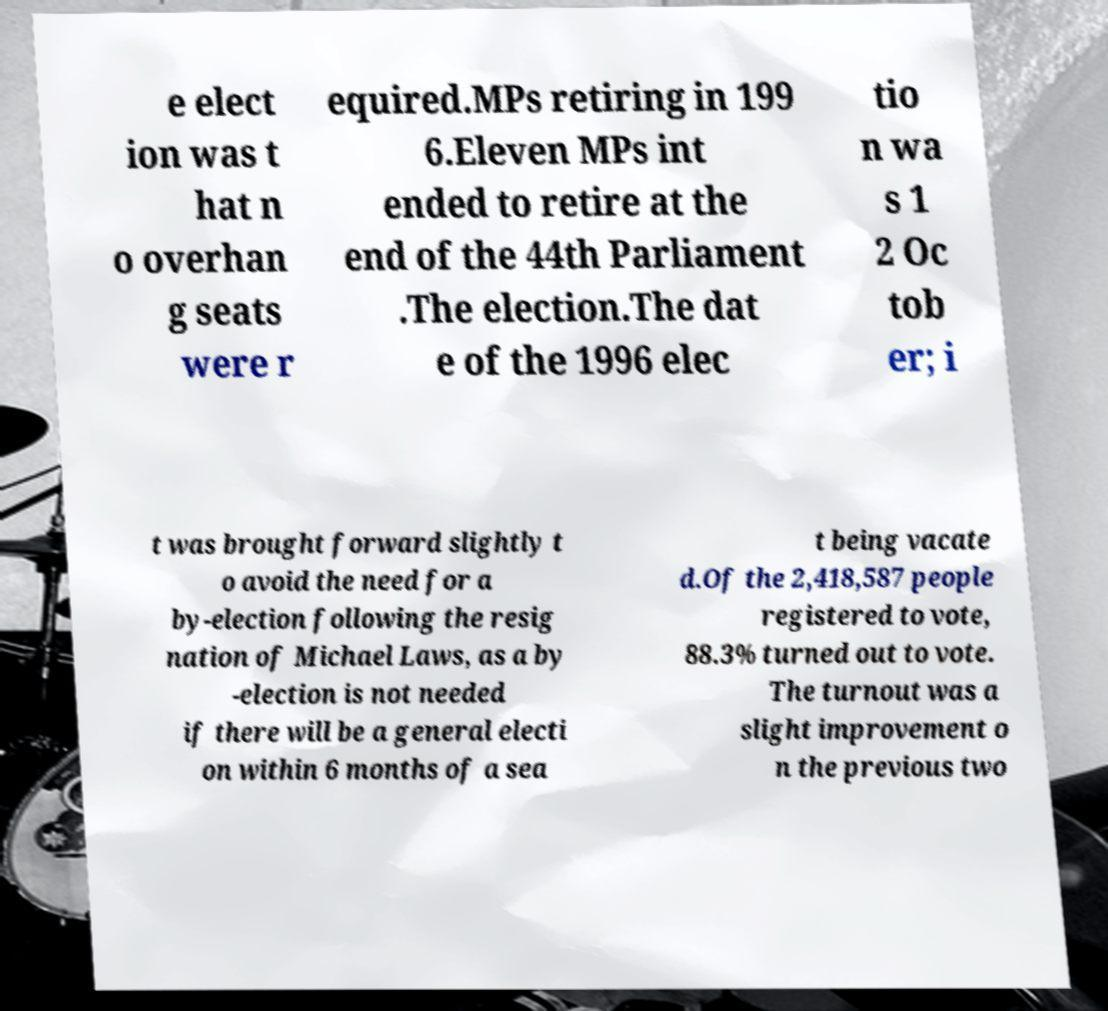Could you assist in decoding the text presented in this image and type it out clearly? e elect ion was t hat n o overhan g seats were r equired.MPs retiring in 199 6.Eleven MPs int ended to retire at the end of the 44th Parliament .The election.The dat e of the 1996 elec tio n wa s 1 2 Oc tob er; i t was brought forward slightly t o avoid the need for a by-election following the resig nation of Michael Laws, as a by -election is not needed if there will be a general electi on within 6 months of a sea t being vacate d.Of the 2,418,587 people registered to vote, 88.3% turned out to vote. The turnout was a slight improvement o n the previous two 